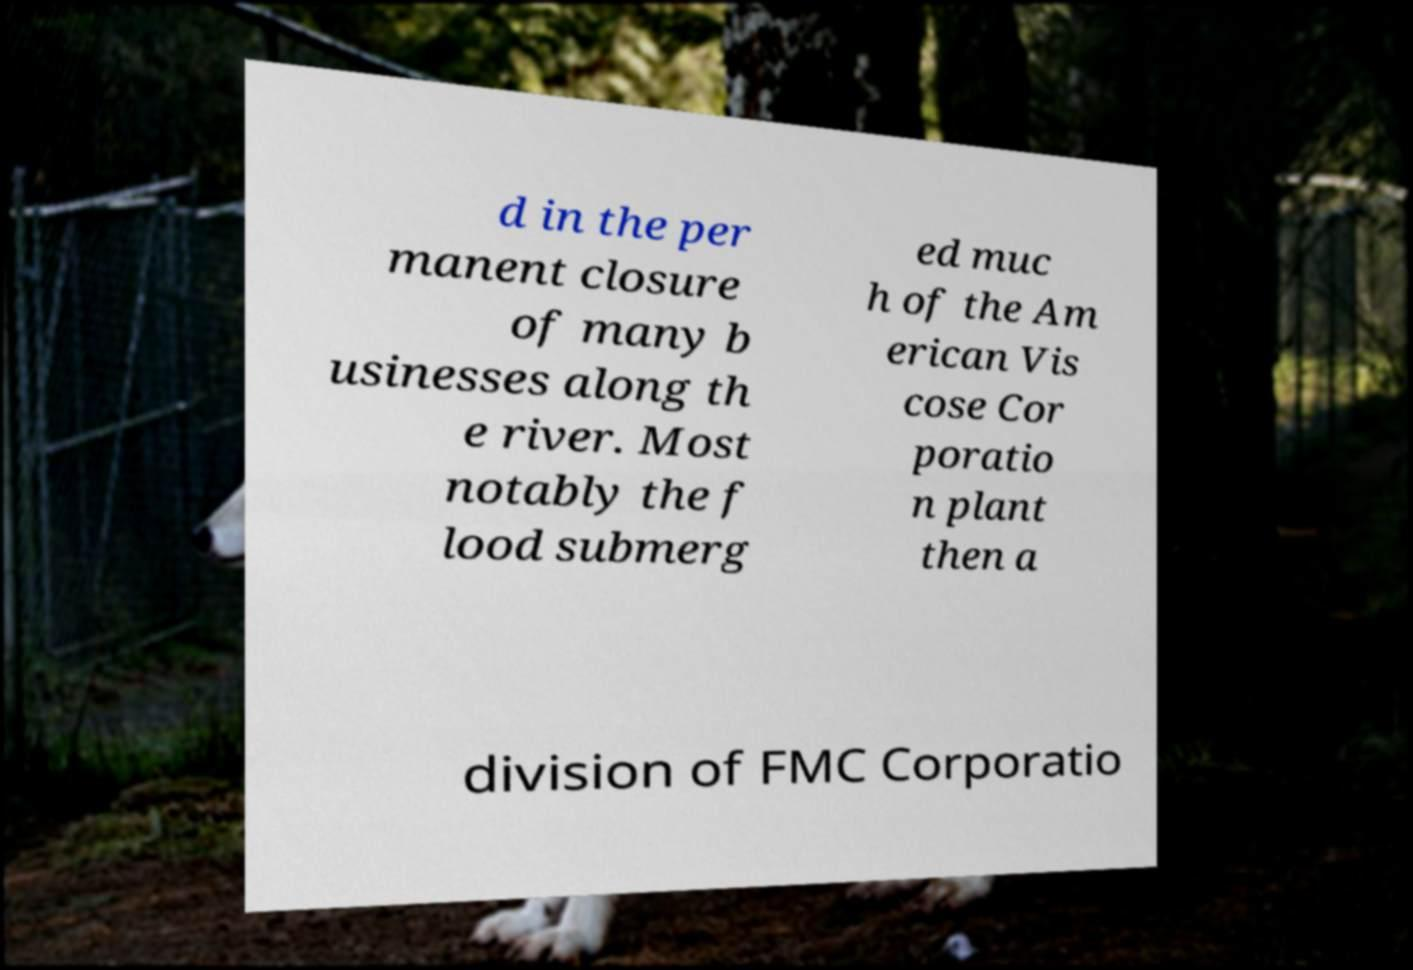I need the written content from this picture converted into text. Can you do that? d in the per manent closure of many b usinesses along th e river. Most notably the f lood submerg ed muc h of the Am erican Vis cose Cor poratio n plant then a division of FMC Corporatio 